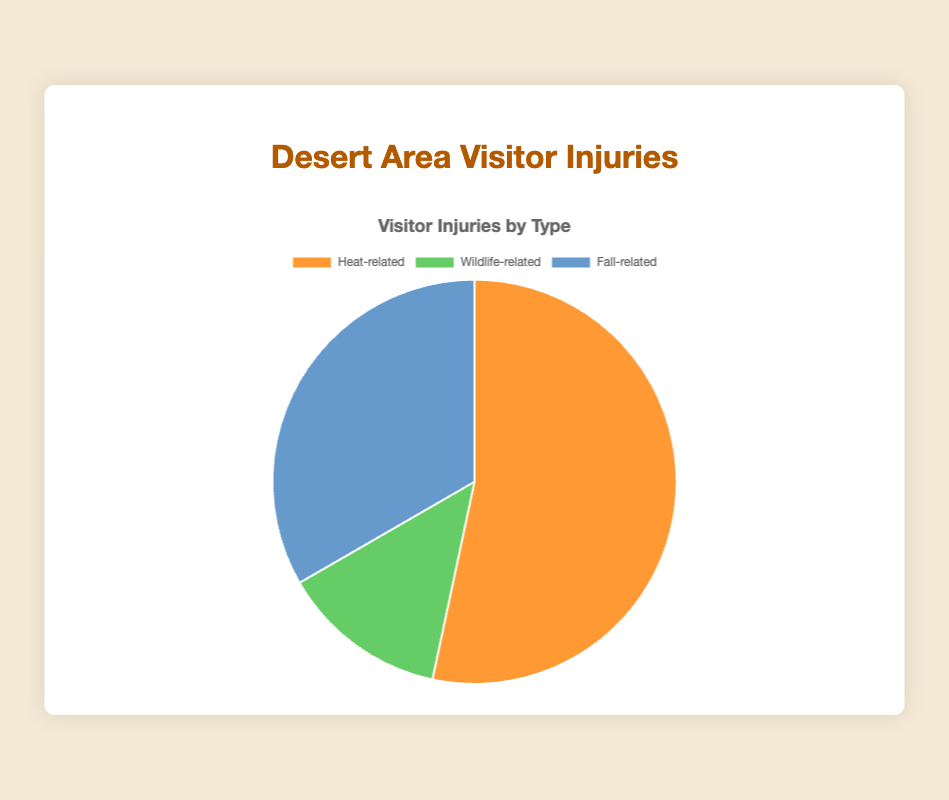What percentage of incidents are heat-related? Heat-related incidents are 40 out of a total of (40 + 10 + 25) = 75 incidents. The percentage is calculated as (40/75) * 100 = 53.33%.
Answer: 53.33% Which type of injury is the least common? By comparing the three data points (40, 10, 25), wildlife-related incidents are the least common because 10 is the smallest number.
Answer: Wildlife-related How does the number of fall-related incidents compare to wildlife-related incidents? Fall-related incidents are 25 while wildlife-related incidents are 10. 25 is greater than 10.
Answer: Fall-related incidents are greater What is the total number of incidents represented in the pie chart? Sum of all incidents: 40 (Heat-related) + 10 (Wildlife-related) + 25 (Fall-related) = 75.
Answer: 75 What percentage of incidents are not heat-related? Total non-heat-related incidents: 10 (Wildlife-related) + 25 (Fall-related) = 35. The percentage is (35/75) * 100 = 46.67%.
Answer: 46.67% By how much do heat-related incidents outnumber wildlife-related incidents? Heat-related incidents are 40, wildlife-related are 10. The difference is 40 - 10 = 30.
Answer: 30 What is the ratio of heat-related to fall-related incidents? Heat-related incidents = 40, fall-related incidents = 25. The ratio is 40:25, simplified to 8:5.
Answer: 8:5 If the total number of incidents increased by 10% next year while keeping the proportions the same, what would be the new number of wildlife-related incidents? Total incidents currently = 75. A 10% increase would make it 75 * 1.10 = 82.5. Wildlife-related incidents proportion is 10/75. The new number is (10/75) * 82.5 = 11 incidents (rounded).
Answer: 11 